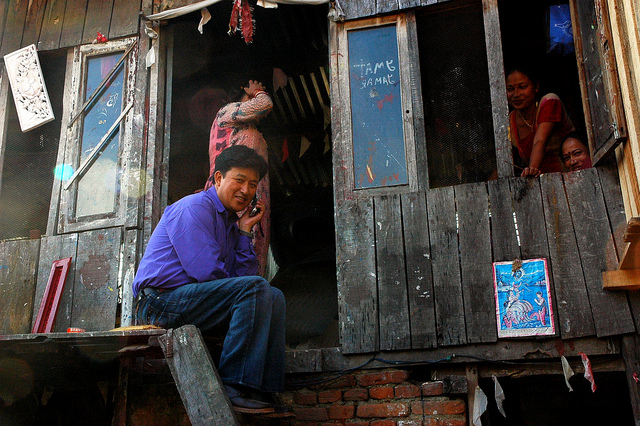Please transcribe the text in this image. Time AMAG 